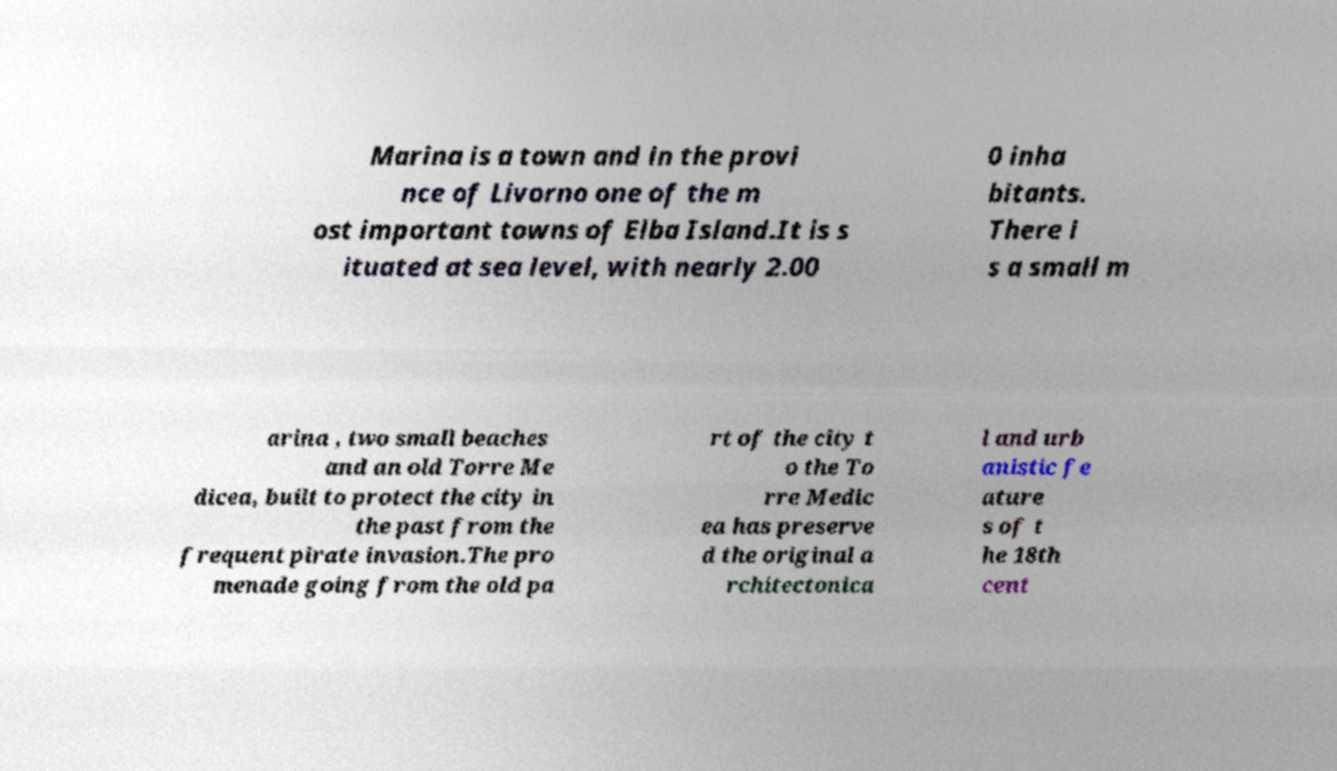Please identify and transcribe the text found in this image. Marina is a town and in the provi nce of Livorno one of the m ost important towns of Elba Island.It is s ituated at sea level, with nearly 2.00 0 inha bitants. There i s a small m arina , two small beaches and an old Torre Me dicea, built to protect the city in the past from the frequent pirate invasion.The pro menade going from the old pa rt of the city t o the To rre Medic ea has preserve d the original a rchitectonica l and urb anistic fe ature s of t he 18th cent 